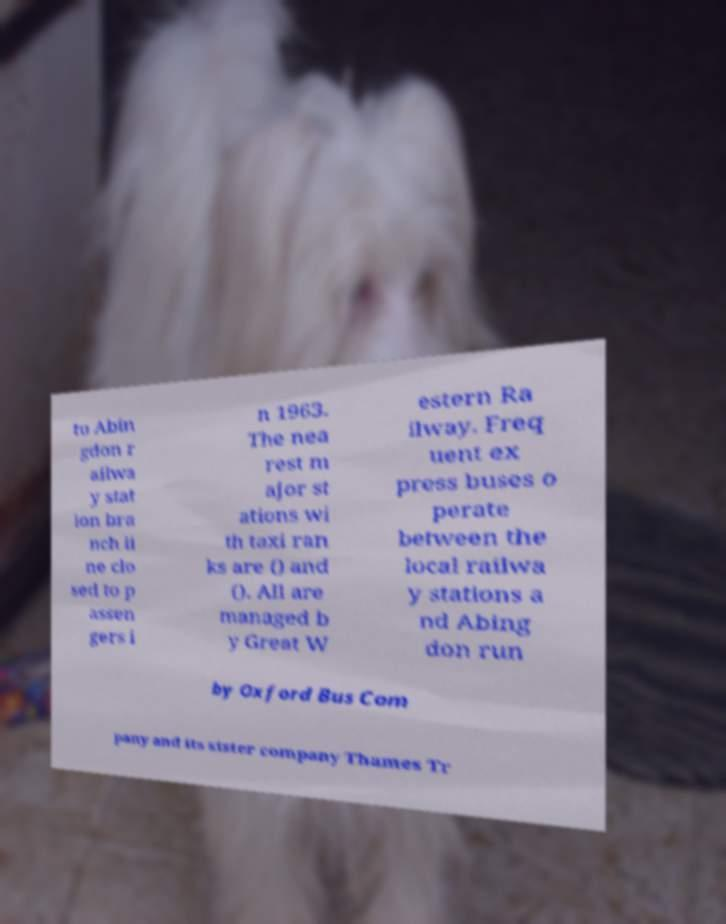Could you assist in decoding the text presented in this image and type it out clearly? to Abin gdon r ailwa y stat ion bra nch li ne clo sed to p assen gers i n 1963. The nea rest m ajor st ations wi th taxi ran ks are () and (). All are managed b y Great W estern Ra ilway. Freq uent ex press buses o perate between the local railwa y stations a nd Abing don run by Oxford Bus Com pany and its sister company Thames Tr 